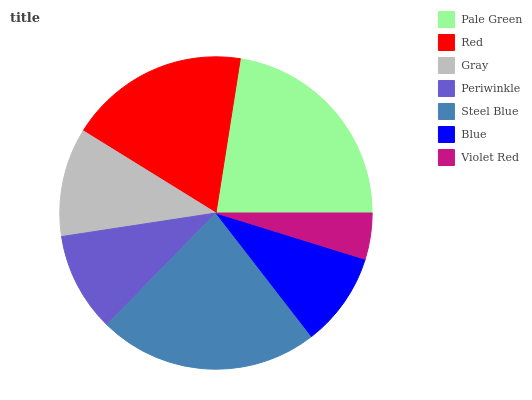Is Violet Red the minimum?
Answer yes or no. Yes. Is Steel Blue the maximum?
Answer yes or no. Yes. Is Red the minimum?
Answer yes or no. No. Is Red the maximum?
Answer yes or no. No. Is Pale Green greater than Red?
Answer yes or no. Yes. Is Red less than Pale Green?
Answer yes or no. Yes. Is Red greater than Pale Green?
Answer yes or no. No. Is Pale Green less than Red?
Answer yes or no. No. Is Gray the high median?
Answer yes or no. Yes. Is Gray the low median?
Answer yes or no. Yes. Is Blue the high median?
Answer yes or no. No. Is Steel Blue the low median?
Answer yes or no. No. 